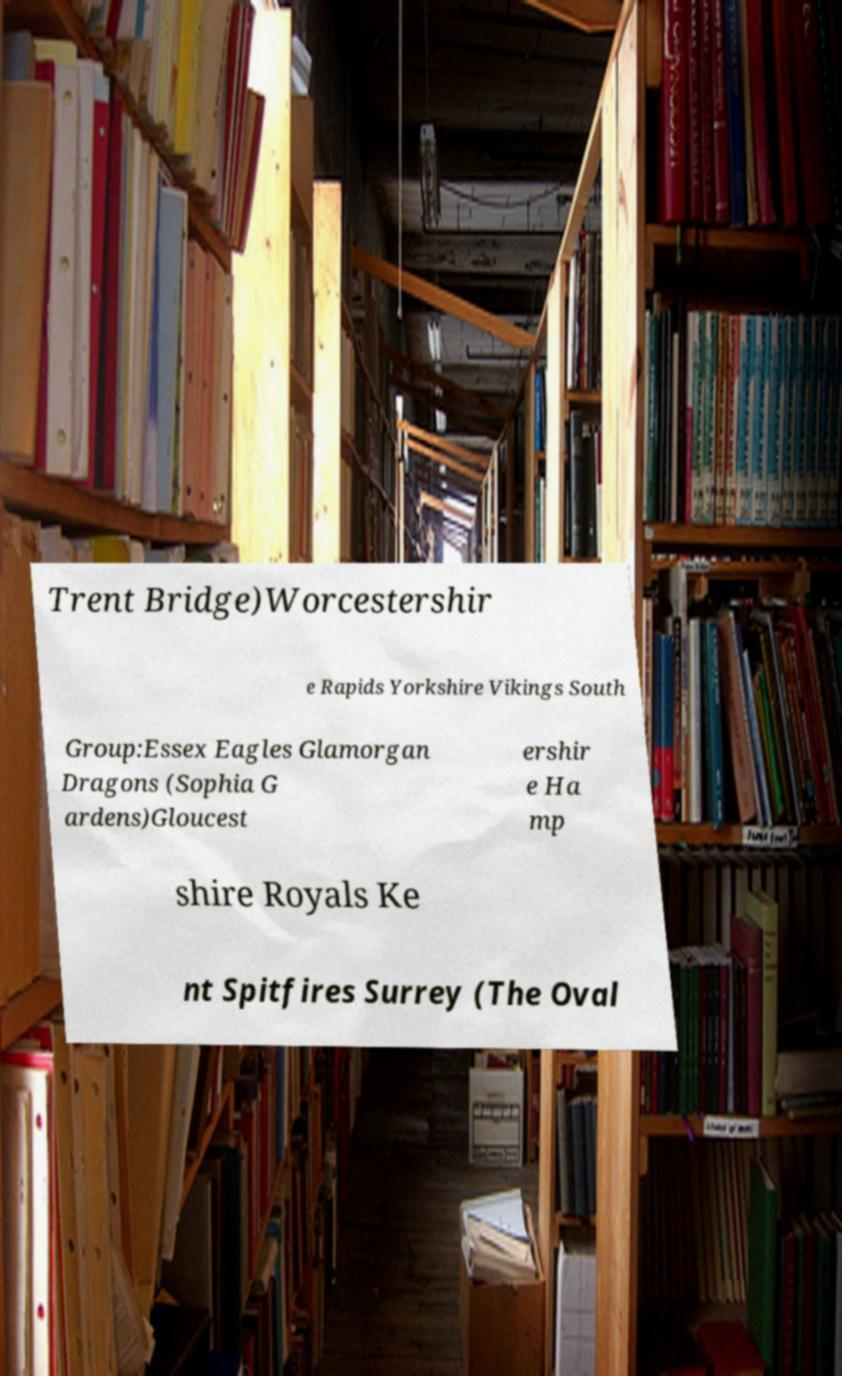For documentation purposes, I need the text within this image transcribed. Could you provide that? Trent Bridge)Worcestershir e Rapids Yorkshire Vikings South Group:Essex Eagles Glamorgan Dragons (Sophia G ardens)Gloucest ershir e Ha mp shire Royals Ke nt Spitfires Surrey (The Oval 